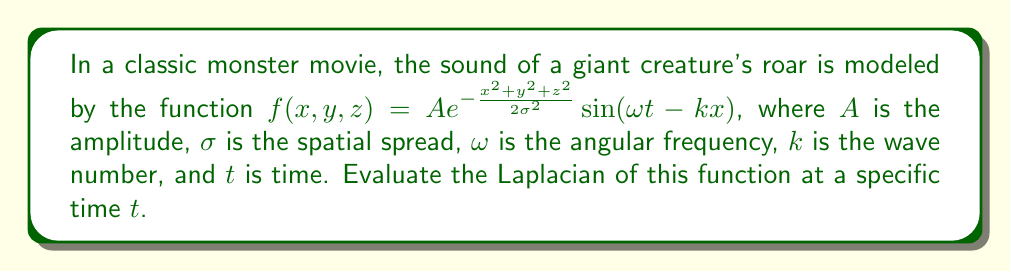What is the answer to this math problem? Let's approach this step-by-step:

1) The Laplacian in 3D Cartesian coordinates is given by:

   $$\nabla^2 f = \frac{\partial^2 f}{\partial x^2} + \frac{\partial^2 f}{\partial y^2} + \frac{\partial^2 f}{\partial z^2}$$

2) Let's calculate each second partial derivative:

   a) For $\frac{\partial^2 f}{\partial x^2}$:
      First, $\frac{\partial f}{\partial x} = A e^{-\frac{x^2 + y^2 + z^2}{2\sigma^2}} \left(-\frac{x}{\sigma^2}\sin(\omega t - kx) - k\cos(\omega t - kx)\right)$
      Then, $\frac{\partial^2 f}{\partial x^2} = A e^{-\frac{x^2 + y^2 + z^2}{2\sigma^2}} \left[\left(\frac{x^2}{\sigma^4} - \frac{1}{\sigma^2}\right)\sin(\omega t - kx) + \frac{2kx}{\sigma^2}\cos(\omega t - kx) - k^2\sin(\omega t - kx)\right]$

   b) For $\frac{\partial^2 f}{\partial y^2}$:
      $\frac{\partial^2 f}{\partial y^2} = A e^{-\frac{x^2 + y^2 + z^2}{2\sigma^2}} \left(\frac{y^2}{\sigma^4} - \frac{1}{\sigma^2}\right)\sin(\omega t - kx)$

   c) For $\frac{\partial^2 f}{\partial z^2}$:
      $\frac{\partial^2 f}{\partial z^2} = A e^{-\frac{x^2 + y^2 + z^2}{2\sigma^2}} \left(\frac{z^2}{\sigma^4} - \frac{1}{\sigma^2}\right)\sin(\omega t - kx)$

3) Now, we sum these to get the Laplacian:

   $$\begin{align}
   \nabla^2 f &= A e^{-\frac{x^2 + y^2 + z^2}{2\sigma^2}} \left[\left(\frac{x^2 + y^2 + z^2}{\sigma^4} - \frac{3}{\sigma^2} - k^2\right)\sin(\omega t - kx) + \frac{2kx}{\sigma^2}\cos(\omega t - kx)\right] \\
   &= A e^{-\frac{x^2 + y^2 + z^2}{2\sigma^2}} \left[\left(\frac{r^2}{\sigma^4} - \frac{3}{\sigma^2} - k^2\right)\sin(\omega t - kx) + \frac{2kx}{\sigma^2}\cos(\omega t - kx)\right]
   \end{align}$$

   where $r^2 = x^2 + y^2 + z^2$.

This is the Laplacian of the function representing the sound waves of the monster's roar at any point $(x, y, z)$ and time $t$.
Answer: $$A e^{-\frac{r^2}{2\sigma^2}} \left[\left(\frac{r^2}{\sigma^4} - \frac{3}{\sigma^2} - k^2\right)\sin(\omega t - kx) + \frac{2kx}{\sigma^2}\cos(\omega t - kx)\right]$$ 